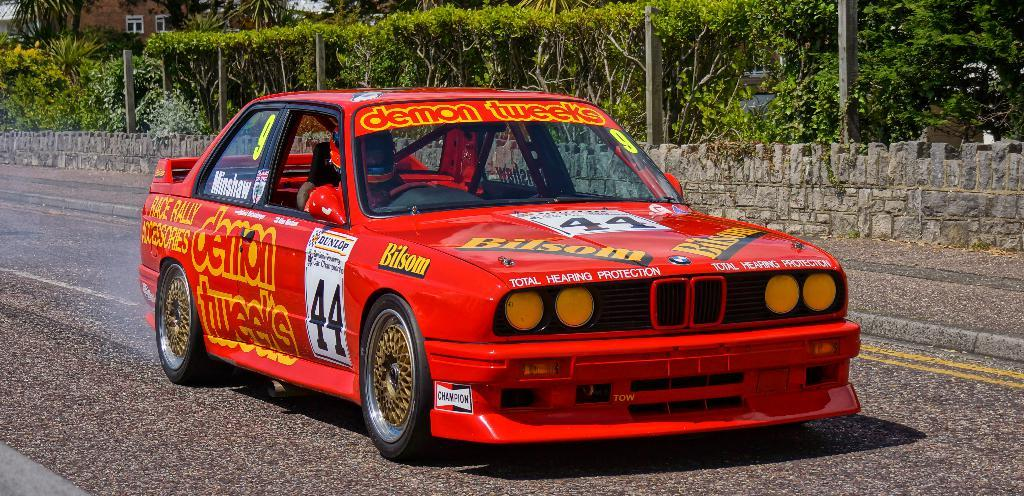What is the main subject of the image? The main subject of the image is a car. Where is the car located in the image? The car is on the road in the image. Who or what is inside the car? There is a person riding in the car. What can be seen in the background of the image? There are plants and trees in the background of the image. Where is the nest located in the image? There is no nest present in the image. What type of bed can be seen in the image? There is no bed present in the image. 